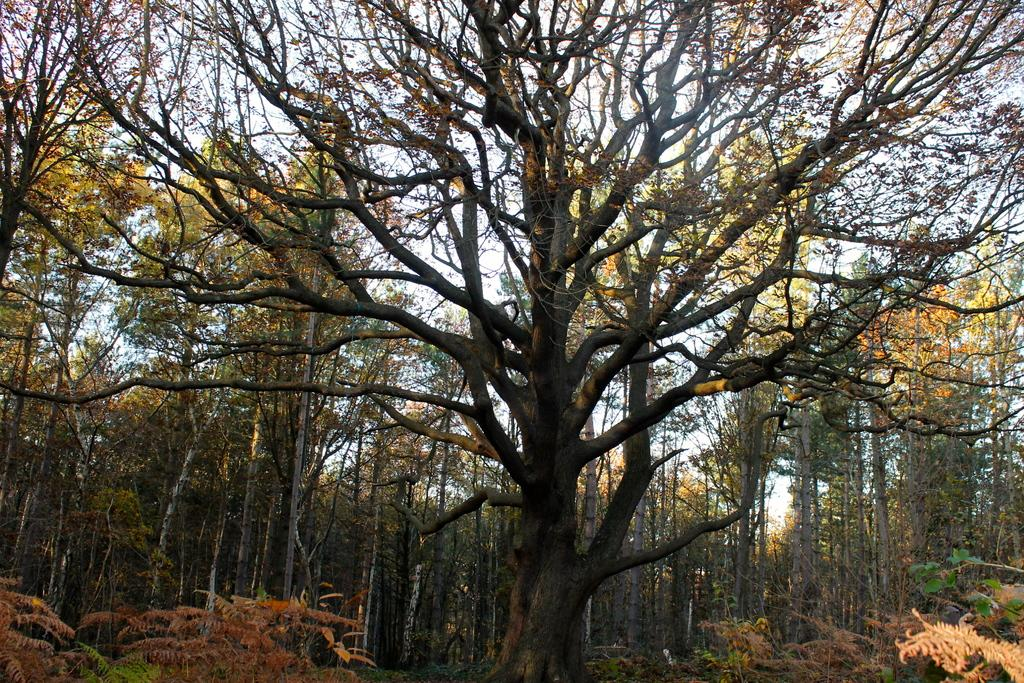What type of vegetation can be seen in the image? There are trees in the image. What is located between the trees on the left side? There is a pole between the trees on the left side. What other type of vegetation is present at the bottom of the image? There are plants at the bottom of the image. What is visible at the top of the image? The sky is visible at the top of the image. What type of juice is being squeezed from the trees in the image? There is no juice being squeezed from the trees in the image; it only shows trees, a pole, plants, and the sky. Can you see a carpenter working on the pole in the image? There is no carpenter present in the image, nor is there any indication of someone working on the pole. 